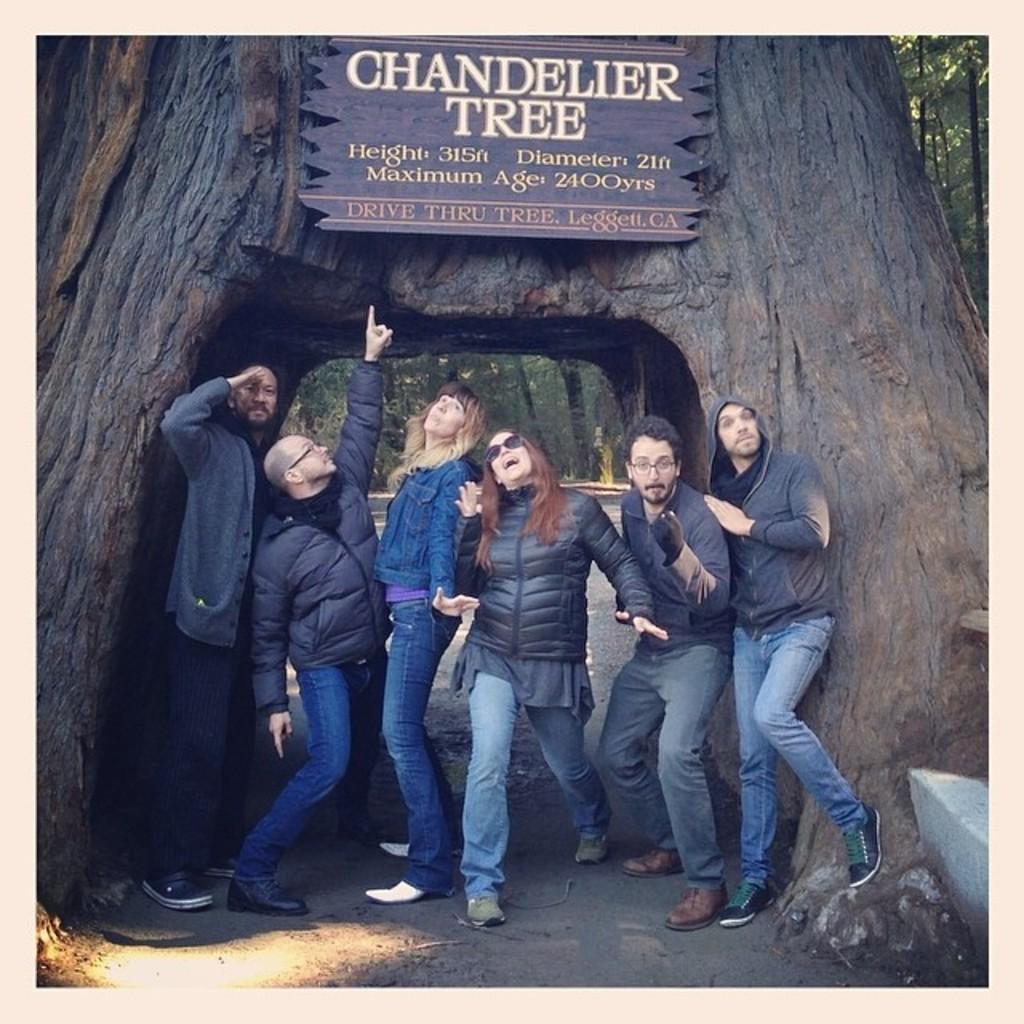Can you describe this image briefly? In this image I can see in the middle 2 ladies are smiling and dancing, 4 men are also smiling they wore coats. At the top there is the board to this bark of a tree. At the back side there are trees. 